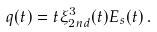Convert formula to latex. <formula><loc_0><loc_0><loc_500><loc_500>q ( t ) = t \xi _ { 2 n d } ^ { 3 } ( t ) E _ { s } ( t ) \, .</formula> 